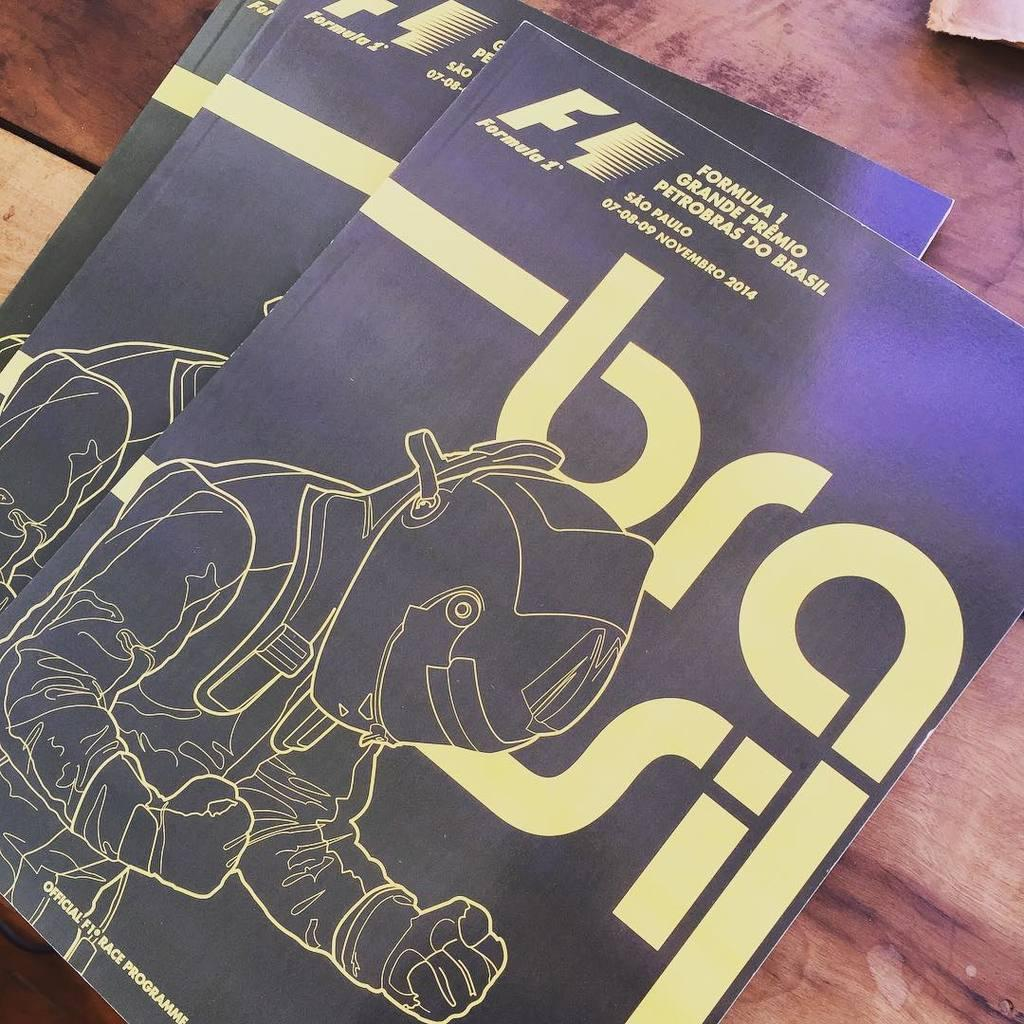<image>
Offer a succinct explanation of the picture presented. a magazing that says 'formula 1 grande premio petrobras do brasil' at the top left 